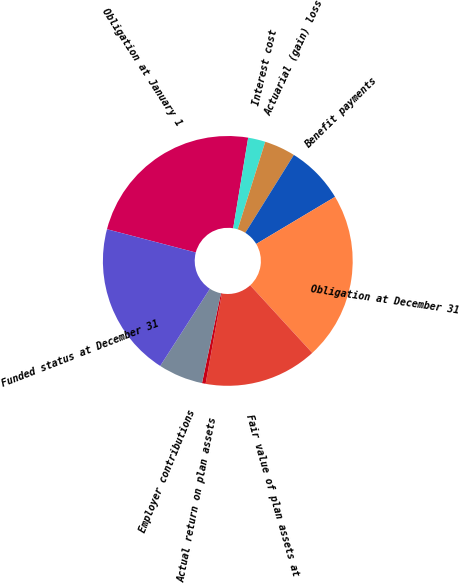Convert chart. <chart><loc_0><loc_0><loc_500><loc_500><pie_chart><fcel>Obligation at January 1<fcel>Interest cost<fcel>Actuarial (gain) loss<fcel>Benefit payments<fcel>Obligation at December 31<fcel>Fair value of plan assets at<fcel>Actual return on plan assets<fcel>Employer contributions<fcel>Funded status at December 31<nl><fcel>23.53%<fcel>2.24%<fcel>4.02%<fcel>7.56%<fcel>21.75%<fcel>14.66%<fcel>0.47%<fcel>5.79%<fcel>19.98%<nl></chart> 